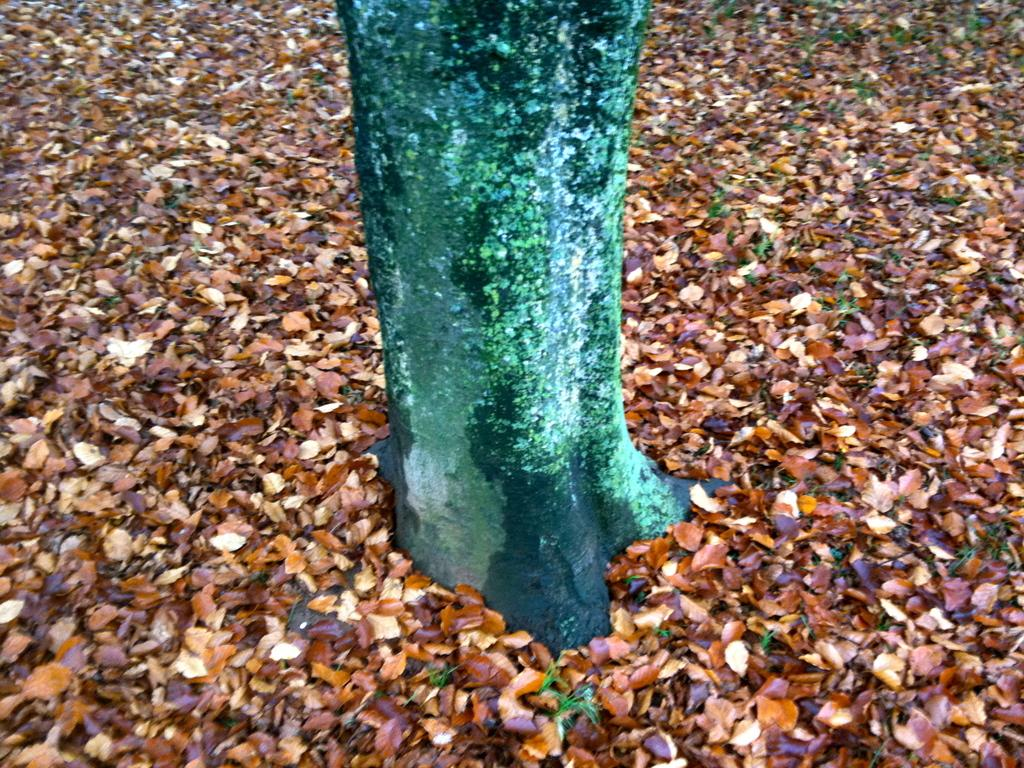What is the main subject in the middle of the image? There is a tree in the middle of the image. What part of the tree can be seen at the bottom of the image? There are leaves visible at the bottom of the image. What type of division is being performed on the tree in the image? There is no division being performed on the tree in the image. What color is the sock hanging from the tree in the image? There is no sock present in the image. What tool is being used to hammer nails into the tree in the image? There is no tool or hammering activity present in the image. 